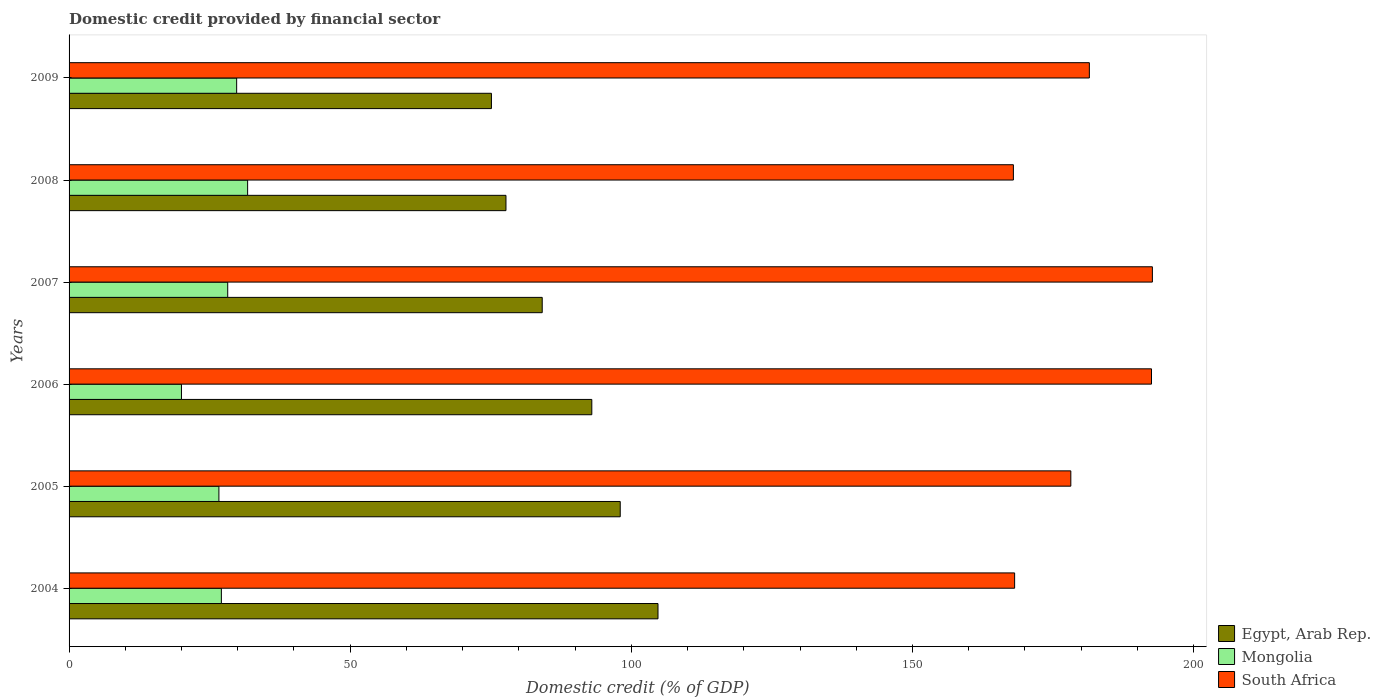How many groups of bars are there?
Your answer should be compact. 6. Are the number of bars per tick equal to the number of legend labels?
Keep it short and to the point. Yes. Are the number of bars on each tick of the Y-axis equal?
Make the answer very short. Yes. How many bars are there on the 4th tick from the top?
Ensure brevity in your answer.  3. How many bars are there on the 6th tick from the bottom?
Your response must be concise. 3. In how many cases, is the number of bars for a given year not equal to the number of legend labels?
Offer a terse response. 0. What is the domestic credit in Egypt, Arab Rep. in 2005?
Your response must be concise. 98.02. Across all years, what is the maximum domestic credit in Mongolia?
Offer a terse response. 31.76. Across all years, what is the minimum domestic credit in South Africa?
Ensure brevity in your answer.  167.94. In which year was the domestic credit in Egypt, Arab Rep. maximum?
Your answer should be very brief. 2004. What is the total domestic credit in Egypt, Arab Rep. in the graph?
Keep it short and to the point. 532.68. What is the difference between the domestic credit in Egypt, Arab Rep. in 2005 and that in 2007?
Offer a very short reply. 13.87. What is the difference between the domestic credit in Egypt, Arab Rep. in 2004 and the domestic credit in Mongolia in 2009?
Your answer should be compact. 74.93. What is the average domestic credit in South Africa per year?
Keep it short and to the point. 180.14. In the year 2005, what is the difference between the domestic credit in Egypt, Arab Rep. and domestic credit in South Africa?
Offer a terse response. -80.13. In how many years, is the domestic credit in South Africa greater than 80 %?
Provide a succinct answer. 6. What is the ratio of the domestic credit in South Africa in 2007 to that in 2009?
Provide a succinct answer. 1.06. Is the domestic credit in South Africa in 2005 less than that in 2007?
Make the answer very short. Yes. Is the difference between the domestic credit in Egypt, Arab Rep. in 2006 and 2009 greater than the difference between the domestic credit in South Africa in 2006 and 2009?
Ensure brevity in your answer.  Yes. What is the difference between the highest and the second highest domestic credit in South Africa?
Offer a terse response. 0.16. What is the difference between the highest and the lowest domestic credit in South Africa?
Your answer should be compact. 24.72. Is the sum of the domestic credit in Egypt, Arab Rep. in 2005 and 2006 greater than the maximum domestic credit in South Africa across all years?
Offer a very short reply. No. What does the 3rd bar from the top in 2005 represents?
Ensure brevity in your answer.  Egypt, Arab Rep. What does the 3rd bar from the bottom in 2005 represents?
Keep it short and to the point. South Africa. How many bars are there?
Keep it short and to the point. 18. What is the difference between two consecutive major ticks on the X-axis?
Your answer should be very brief. 50. Are the values on the major ticks of X-axis written in scientific E-notation?
Give a very brief answer. No. Does the graph contain any zero values?
Your answer should be compact. No. Does the graph contain grids?
Make the answer very short. No. Where does the legend appear in the graph?
Offer a very short reply. Bottom right. How many legend labels are there?
Your response must be concise. 3. How are the legend labels stacked?
Ensure brevity in your answer.  Vertical. What is the title of the graph?
Keep it short and to the point. Domestic credit provided by financial sector. What is the label or title of the X-axis?
Provide a short and direct response. Domestic credit (% of GDP). What is the Domestic credit (% of GDP) in Egypt, Arab Rep. in 2004?
Provide a short and direct response. 104.74. What is the Domestic credit (% of GDP) in Mongolia in 2004?
Make the answer very short. 27.09. What is the Domestic credit (% of GDP) of South Africa in 2004?
Offer a very short reply. 168.16. What is the Domestic credit (% of GDP) of Egypt, Arab Rep. in 2005?
Your answer should be compact. 98.02. What is the Domestic credit (% of GDP) in Mongolia in 2005?
Your answer should be compact. 26.65. What is the Domestic credit (% of GDP) in South Africa in 2005?
Your answer should be compact. 178.16. What is the Domestic credit (% of GDP) in Egypt, Arab Rep. in 2006?
Keep it short and to the point. 92.97. What is the Domestic credit (% of GDP) in Mongolia in 2006?
Offer a terse response. 19.99. What is the Domestic credit (% of GDP) in South Africa in 2006?
Keep it short and to the point. 192.5. What is the Domestic credit (% of GDP) in Egypt, Arab Rep. in 2007?
Ensure brevity in your answer.  84.15. What is the Domestic credit (% of GDP) in Mongolia in 2007?
Your answer should be compact. 28.21. What is the Domestic credit (% of GDP) in South Africa in 2007?
Keep it short and to the point. 192.66. What is the Domestic credit (% of GDP) of Egypt, Arab Rep. in 2008?
Provide a succinct answer. 77.7. What is the Domestic credit (% of GDP) in Mongolia in 2008?
Give a very brief answer. 31.76. What is the Domestic credit (% of GDP) in South Africa in 2008?
Offer a very short reply. 167.94. What is the Domestic credit (% of GDP) of Egypt, Arab Rep. in 2009?
Keep it short and to the point. 75.11. What is the Domestic credit (% of GDP) of Mongolia in 2009?
Your answer should be compact. 29.8. What is the Domestic credit (% of GDP) of South Africa in 2009?
Make the answer very short. 181.45. Across all years, what is the maximum Domestic credit (% of GDP) of Egypt, Arab Rep.?
Make the answer very short. 104.74. Across all years, what is the maximum Domestic credit (% of GDP) in Mongolia?
Offer a terse response. 31.76. Across all years, what is the maximum Domestic credit (% of GDP) in South Africa?
Provide a short and direct response. 192.66. Across all years, what is the minimum Domestic credit (% of GDP) in Egypt, Arab Rep.?
Ensure brevity in your answer.  75.11. Across all years, what is the minimum Domestic credit (% of GDP) of Mongolia?
Provide a succinct answer. 19.99. Across all years, what is the minimum Domestic credit (% of GDP) in South Africa?
Provide a succinct answer. 167.94. What is the total Domestic credit (% of GDP) in Egypt, Arab Rep. in the graph?
Your answer should be very brief. 532.68. What is the total Domestic credit (% of GDP) of Mongolia in the graph?
Your answer should be very brief. 163.49. What is the total Domestic credit (% of GDP) in South Africa in the graph?
Your answer should be very brief. 1080.87. What is the difference between the Domestic credit (% of GDP) in Egypt, Arab Rep. in 2004 and that in 2005?
Provide a succinct answer. 6.72. What is the difference between the Domestic credit (% of GDP) of Mongolia in 2004 and that in 2005?
Give a very brief answer. 0.44. What is the difference between the Domestic credit (% of GDP) in South Africa in 2004 and that in 2005?
Your answer should be compact. -10. What is the difference between the Domestic credit (% of GDP) of Egypt, Arab Rep. in 2004 and that in 2006?
Your response must be concise. 11.77. What is the difference between the Domestic credit (% of GDP) in Mongolia in 2004 and that in 2006?
Your response must be concise. 7.1. What is the difference between the Domestic credit (% of GDP) in South Africa in 2004 and that in 2006?
Your response must be concise. -24.34. What is the difference between the Domestic credit (% of GDP) in Egypt, Arab Rep. in 2004 and that in 2007?
Give a very brief answer. 20.59. What is the difference between the Domestic credit (% of GDP) of Mongolia in 2004 and that in 2007?
Provide a short and direct response. -1.13. What is the difference between the Domestic credit (% of GDP) of South Africa in 2004 and that in 2007?
Offer a terse response. -24.5. What is the difference between the Domestic credit (% of GDP) of Egypt, Arab Rep. in 2004 and that in 2008?
Keep it short and to the point. 27.04. What is the difference between the Domestic credit (% of GDP) of Mongolia in 2004 and that in 2008?
Offer a very short reply. -4.67. What is the difference between the Domestic credit (% of GDP) of South Africa in 2004 and that in 2008?
Make the answer very short. 0.22. What is the difference between the Domestic credit (% of GDP) in Egypt, Arab Rep. in 2004 and that in 2009?
Offer a terse response. 29.62. What is the difference between the Domestic credit (% of GDP) of Mongolia in 2004 and that in 2009?
Offer a terse response. -2.72. What is the difference between the Domestic credit (% of GDP) in South Africa in 2004 and that in 2009?
Make the answer very short. -13.29. What is the difference between the Domestic credit (% of GDP) in Egypt, Arab Rep. in 2005 and that in 2006?
Offer a very short reply. 5.05. What is the difference between the Domestic credit (% of GDP) in Mongolia in 2005 and that in 2006?
Offer a very short reply. 6.66. What is the difference between the Domestic credit (% of GDP) in South Africa in 2005 and that in 2006?
Provide a short and direct response. -14.35. What is the difference between the Domestic credit (% of GDP) of Egypt, Arab Rep. in 2005 and that in 2007?
Make the answer very short. 13.87. What is the difference between the Domestic credit (% of GDP) in Mongolia in 2005 and that in 2007?
Your answer should be compact. -1.57. What is the difference between the Domestic credit (% of GDP) in South Africa in 2005 and that in 2007?
Give a very brief answer. -14.5. What is the difference between the Domestic credit (% of GDP) of Egypt, Arab Rep. in 2005 and that in 2008?
Ensure brevity in your answer.  20.32. What is the difference between the Domestic credit (% of GDP) of Mongolia in 2005 and that in 2008?
Make the answer very short. -5.11. What is the difference between the Domestic credit (% of GDP) of South Africa in 2005 and that in 2008?
Ensure brevity in your answer.  10.21. What is the difference between the Domestic credit (% of GDP) in Egypt, Arab Rep. in 2005 and that in 2009?
Provide a short and direct response. 22.91. What is the difference between the Domestic credit (% of GDP) in Mongolia in 2005 and that in 2009?
Provide a succinct answer. -3.16. What is the difference between the Domestic credit (% of GDP) of South Africa in 2005 and that in 2009?
Provide a short and direct response. -3.29. What is the difference between the Domestic credit (% of GDP) of Egypt, Arab Rep. in 2006 and that in 2007?
Give a very brief answer. 8.82. What is the difference between the Domestic credit (% of GDP) in Mongolia in 2006 and that in 2007?
Offer a very short reply. -8.23. What is the difference between the Domestic credit (% of GDP) of South Africa in 2006 and that in 2007?
Your response must be concise. -0.16. What is the difference between the Domestic credit (% of GDP) in Egypt, Arab Rep. in 2006 and that in 2008?
Give a very brief answer. 15.27. What is the difference between the Domestic credit (% of GDP) in Mongolia in 2006 and that in 2008?
Offer a very short reply. -11.77. What is the difference between the Domestic credit (% of GDP) in South Africa in 2006 and that in 2008?
Offer a terse response. 24.56. What is the difference between the Domestic credit (% of GDP) in Egypt, Arab Rep. in 2006 and that in 2009?
Offer a very short reply. 17.85. What is the difference between the Domestic credit (% of GDP) in Mongolia in 2006 and that in 2009?
Ensure brevity in your answer.  -9.82. What is the difference between the Domestic credit (% of GDP) of South Africa in 2006 and that in 2009?
Your answer should be very brief. 11.05. What is the difference between the Domestic credit (% of GDP) in Egypt, Arab Rep. in 2007 and that in 2008?
Make the answer very short. 6.45. What is the difference between the Domestic credit (% of GDP) of Mongolia in 2007 and that in 2008?
Your response must be concise. -3.54. What is the difference between the Domestic credit (% of GDP) in South Africa in 2007 and that in 2008?
Your answer should be very brief. 24.72. What is the difference between the Domestic credit (% of GDP) in Egypt, Arab Rep. in 2007 and that in 2009?
Make the answer very short. 9.03. What is the difference between the Domestic credit (% of GDP) of Mongolia in 2007 and that in 2009?
Offer a terse response. -1.59. What is the difference between the Domestic credit (% of GDP) in South Africa in 2007 and that in 2009?
Provide a succinct answer. 11.21. What is the difference between the Domestic credit (% of GDP) of Egypt, Arab Rep. in 2008 and that in 2009?
Your answer should be very brief. 2.58. What is the difference between the Domestic credit (% of GDP) of Mongolia in 2008 and that in 2009?
Offer a very short reply. 1.95. What is the difference between the Domestic credit (% of GDP) of South Africa in 2008 and that in 2009?
Your response must be concise. -13.51. What is the difference between the Domestic credit (% of GDP) in Egypt, Arab Rep. in 2004 and the Domestic credit (% of GDP) in Mongolia in 2005?
Your answer should be compact. 78.09. What is the difference between the Domestic credit (% of GDP) of Egypt, Arab Rep. in 2004 and the Domestic credit (% of GDP) of South Africa in 2005?
Keep it short and to the point. -73.42. What is the difference between the Domestic credit (% of GDP) in Mongolia in 2004 and the Domestic credit (% of GDP) in South Africa in 2005?
Your answer should be very brief. -151.07. What is the difference between the Domestic credit (% of GDP) of Egypt, Arab Rep. in 2004 and the Domestic credit (% of GDP) of Mongolia in 2006?
Your response must be concise. 84.75. What is the difference between the Domestic credit (% of GDP) of Egypt, Arab Rep. in 2004 and the Domestic credit (% of GDP) of South Africa in 2006?
Offer a terse response. -87.77. What is the difference between the Domestic credit (% of GDP) in Mongolia in 2004 and the Domestic credit (% of GDP) in South Africa in 2006?
Provide a succinct answer. -165.42. What is the difference between the Domestic credit (% of GDP) in Egypt, Arab Rep. in 2004 and the Domestic credit (% of GDP) in Mongolia in 2007?
Make the answer very short. 76.52. What is the difference between the Domestic credit (% of GDP) of Egypt, Arab Rep. in 2004 and the Domestic credit (% of GDP) of South Africa in 2007?
Give a very brief answer. -87.92. What is the difference between the Domestic credit (% of GDP) in Mongolia in 2004 and the Domestic credit (% of GDP) in South Africa in 2007?
Provide a short and direct response. -165.57. What is the difference between the Domestic credit (% of GDP) of Egypt, Arab Rep. in 2004 and the Domestic credit (% of GDP) of Mongolia in 2008?
Ensure brevity in your answer.  72.98. What is the difference between the Domestic credit (% of GDP) of Egypt, Arab Rep. in 2004 and the Domestic credit (% of GDP) of South Africa in 2008?
Your answer should be very brief. -63.2. What is the difference between the Domestic credit (% of GDP) of Mongolia in 2004 and the Domestic credit (% of GDP) of South Africa in 2008?
Provide a short and direct response. -140.85. What is the difference between the Domestic credit (% of GDP) of Egypt, Arab Rep. in 2004 and the Domestic credit (% of GDP) of Mongolia in 2009?
Ensure brevity in your answer.  74.93. What is the difference between the Domestic credit (% of GDP) of Egypt, Arab Rep. in 2004 and the Domestic credit (% of GDP) of South Africa in 2009?
Ensure brevity in your answer.  -76.71. What is the difference between the Domestic credit (% of GDP) of Mongolia in 2004 and the Domestic credit (% of GDP) of South Africa in 2009?
Ensure brevity in your answer.  -154.36. What is the difference between the Domestic credit (% of GDP) in Egypt, Arab Rep. in 2005 and the Domestic credit (% of GDP) in Mongolia in 2006?
Provide a short and direct response. 78.03. What is the difference between the Domestic credit (% of GDP) in Egypt, Arab Rep. in 2005 and the Domestic credit (% of GDP) in South Africa in 2006?
Provide a succinct answer. -94.48. What is the difference between the Domestic credit (% of GDP) in Mongolia in 2005 and the Domestic credit (% of GDP) in South Africa in 2006?
Your answer should be compact. -165.86. What is the difference between the Domestic credit (% of GDP) of Egypt, Arab Rep. in 2005 and the Domestic credit (% of GDP) of Mongolia in 2007?
Provide a succinct answer. 69.81. What is the difference between the Domestic credit (% of GDP) in Egypt, Arab Rep. in 2005 and the Domestic credit (% of GDP) in South Africa in 2007?
Offer a very short reply. -94.64. What is the difference between the Domestic credit (% of GDP) in Mongolia in 2005 and the Domestic credit (% of GDP) in South Africa in 2007?
Ensure brevity in your answer.  -166.01. What is the difference between the Domestic credit (% of GDP) of Egypt, Arab Rep. in 2005 and the Domestic credit (% of GDP) of Mongolia in 2008?
Offer a terse response. 66.27. What is the difference between the Domestic credit (% of GDP) of Egypt, Arab Rep. in 2005 and the Domestic credit (% of GDP) of South Africa in 2008?
Give a very brief answer. -69.92. What is the difference between the Domestic credit (% of GDP) in Mongolia in 2005 and the Domestic credit (% of GDP) in South Africa in 2008?
Give a very brief answer. -141.3. What is the difference between the Domestic credit (% of GDP) of Egypt, Arab Rep. in 2005 and the Domestic credit (% of GDP) of Mongolia in 2009?
Provide a succinct answer. 68.22. What is the difference between the Domestic credit (% of GDP) in Egypt, Arab Rep. in 2005 and the Domestic credit (% of GDP) in South Africa in 2009?
Keep it short and to the point. -83.43. What is the difference between the Domestic credit (% of GDP) in Mongolia in 2005 and the Domestic credit (% of GDP) in South Africa in 2009?
Ensure brevity in your answer.  -154.8. What is the difference between the Domestic credit (% of GDP) of Egypt, Arab Rep. in 2006 and the Domestic credit (% of GDP) of Mongolia in 2007?
Provide a succinct answer. 64.75. What is the difference between the Domestic credit (% of GDP) of Egypt, Arab Rep. in 2006 and the Domestic credit (% of GDP) of South Africa in 2007?
Offer a terse response. -99.69. What is the difference between the Domestic credit (% of GDP) of Mongolia in 2006 and the Domestic credit (% of GDP) of South Africa in 2007?
Provide a short and direct response. -172.67. What is the difference between the Domestic credit (% of GDP) in Egypt, Arab Rep. in 2006 and the Domestic credit (% of GDP) in Mongolia in 2008?
Ensure brevity in your answer.  61.21. What is the difference between the Domestic credit (% of GDP) of Egypt, Arab Rep. in 2006 and the Domestic credit (% of GDP) of South Africa in 2008?
Your answer should be very brief. -74.97. What is the difference between the Domestic credit (% of GDP) of Mongolia in 2006 and the Domestic credit (% of GDP) of South Africa in 2008?
Offer a terse response. -147.95. What is the difference between the Domestic credit (% of GDP) of Egypt, Arab Rep. in 2006 and the Domestic credit (% of GDP) of Mongolia in 2009?
Your answer should be very brief. 63.16. What is the difference between the Domestic credit (% of GDP) of Egypt, Arab Rep. in 2006 and the Domestic credit (% of GDP) of South Africa in 2009?
Give a very brief answer. -88.48. What is the difference between the Domestic credit (% of GDP) of Mongolia in 2006 and the Domestic credit (% of GDP) of South Africa in 2009?
Your answer should be compact. -161.46. What is the difference between the Domestic credit (% of GDP) in Egypt, Arab Rep. in 2007 and the Domestic credit (% of GDP) in Mongolia in 2008?
Provide a succinct answer. 52.39. What is the difference between the Domestic credit (% of GDP) in Egypt, Arab Rep. in 2007 and the Domestic credit (% of GDP) in South Africa in 2008?
Your answer should be compact. -83.79. What is the difference between the Domestic credit (% of GDP) of Mongolia in 2007 and the Domestic credit (% of GDP) of South Africa in 2008?
Your response must be concise. -139.73. What is the difference between the Domestic credit (% of GDP) in Egypt, Arab Rep. in 2007 and the Domestic credit (% of GDP) in Mongolia in 2009?
Offer a terse response. 54.34. What is the difference between the Domestic credit (% of GDP) in Egypt, Arab Rep. in 2007 and the Domestic credit (% of GDP) in South Africa in 2009?
Offer a very short reply. -97.3. What is the difference between the Domestic credit (% of GDP) of Mongolia in 2007 and the Domestic credit (% of GDP) of South Africa in 2009?
Provide a short and direct response. -153.24. What is the difference between the Domestic credit (% of GDP) in Egypt, Arab Rep. in 2008 and the Domestic credit (% of GDP) in Mongolia in 2009?
Keep it short and to the point. 47.89. What is the difference between the Domestic credit (% of GDP) in Egypt, Arab Rep. in 2008 and the Domestic credit (% of GDP) in South Africa in 2009?
Your response must be concise. -103.75. What is the difference between the Domestic credit (% of GDP) in Mongolia in 2008 and the Domestic credit (% of GDP) in South Africa in 2009?
Offer a very short reply. -149.69. What is the average Domestic credit (% of GDP) in Egypt, Arab Rep. per year?
Ensure brevity in your answer.  88.78. What is the average Domestic credit (% of GDP) of Mongolia per year?
Your response must be concise. 27.25. What is the average Domestic credit (% of GDP) in South Africa per year?
Your answer should be compact. 180.14. In the year 2004, what is the difference between the Domestic credit (% of GDP) of Egypt, Arab Rep. and Domestic credit (% of GDP) of Mongolia?
Give a very brief answer. 77.65. In the year 2004, what is the difference between the Domestic credit (% of GDP) in Egypt, Arab Rep. and Domestic credit (% of GDP) in South Africa?
Give a very brief answer. -63.42. In the year 2004, what is the difference between the Domestic credit (% of GDP) of Mongolia and Domestic credit (% of GDP) of South Africa?
Provide a succinct answer. -141.07. In the year 2005, what is the difference between the Domestic credit (% of GDP) of Egypt, Arab Rep. and Domestic credit (% of GDP) of Mongolia?
Ensure brevity in your answer.  71.38. In the year 2005, what is the difference between the Domestic credit (% of GDP) of Egypt, Arab Rep. and Domestic credit (% of GDP) of South Africa?
Ensure brevity in your answer.  -80.13. In the year 2005, what is the difference between the Domestic credit (% of GDP) of Mongolia and Domestic credit (% of GDP) of South Africa?
Offer a very short reply. -151.51. In the year 2006, what is the difference between the Domestic credit (% of GDP) in Egypt, Arab Rep. and Domestic credit (% of GDP) in Mongolia?
Keep it short and to the point. 72.98. In the year 2006, what is the difference between the Domestic credit (% of GDP) of Egypt, Arab Rep. and Domestic credit (% of GDP) of South Africa?
Keep it short and to the point. -99.54. In the year 2006, what is the difference between the Domestic credit (% of GDP) in Mongolia and Domestic credit (% of GDP) in South Africa?
Your answer should be very brief. -172.51. In the year 2007, what is the difference between the Domestic credit (% of GDP) of Egypt, Arab Rep. and Domestic credit (% of GDP) of Mongolia?
Your answer should be very brief. 55.93. In the year 2007, what is the difference between the Domestic credit (% of GDP) in Egypt, Arab Rep. and Domestic credit (% of GDP) in South Africa?
Give a very brief answer. -108.51. In the year 2007, what is the difference between the Domestic credit (% of GDP) in Mongolia and Domestic credit (% of GDP) in South Africa?
Keep it short and to the point. -164.45. In the year 2008, what is the difference between the Domestic credit (% of GDP) of Egypt, Arab Rep. and Domestic credit (% of GDP) of Mongolia?
Provide a short and direct response. 45.94. In the year 2008, what is the difference between the Domestic credit (% of GDP) of Egypt, Arab Rep. and Domestic credit (% of GDP) of South Africa?
Offer a terse response. -90.24. In the year 2008, what is the difference between the Domestic credit (% of GDP) of Mongolia and Domestic credit (% of GDP) of South Africa?
Your response must be concise. -136.19. In the year 2009, what is the difference between the Domestic credit (% of GDP) in Egypt, Arab Rep. and Domestic credit (% of GDP) in Mongolia?
Your answer should be very brief. 45.31. In the year 2009, what is the difference between the Domestic credit (% of GDP) of Egypt, Arab Rep. and Domestic credit (% of GDP) of South Africa?
Your answer should be very brief. -106.34. In the year 2009, what is the difference between the Domestic credit (% of GDP) of Mongolia and Domestic credit (% of GDP) of South Africa?
Your answer should be compact. -151.65. What is the ratio of the Domestic credit (% of GDP) in Egypt, Arab Rep. in 2004 to that in 2005?
Provide a short and direct response. 1.07. What is the ratio of the Domestic credit (% of GDP) of Mongolia in 2004 to that in 2005?
Your answer should be very brief. 1.02. What is the ratio of the Domestic credit (% of GDP) in South Africa in 2004 to that in 2005?
Provide a succinct answer. 0.94. What is the ratio of the Domestic credit (% of GDP) in Egypt, Arab Rep. in 2004 to that in 2006?
Offer a very short reply. 1.13. What is the ratio of the Domestic credit (% of GDP) in Mongolia in 2004 to that in 2006?
Provide a succinct answer. 1.36. What is the ratio of the Domestic credit (% of GDP) in South Africa in 2004 to that in 2006?
Ensure brevity in your answer.  0.87. What is the ratio of the Domestic credit (% of GDP) in Egypt, Arab Rep. in 2004 to that in 2007?
Provide a succinct answer. 1.24. What is the ratio of the Domestic credit (% of GDP) in Mongolia in 2004 to that in 2007?
Keep it short and to the point. 0.96. What is the ratio of the Domestic credit (% of GDP) in South Africa in 2004 to that in 2007?
Your response must be concise. 0.87. What is the ratio of the Domestic credit (% of GDP) in Egypt, Arab Rep. in 2004 to that in 2008?
Your answer should be very brief. 1.35. What is the ratio of the Domestic credit (% of GDP) of Mongolia in 2004 to that in 2008?
Provide a succinct answer. 0.85. What is the ratio of the Domestic credit (% of GDP) of Egypt, Arab Rep. in 2004 to that in 2009?
Offer a very short reply. 1.39. What is the ratio of the Domestic credit (% of GDP) of Mongolia in 2004 to that in 2009?
Give a very brief answer. 0.91. What is the ratio of the Domestic credit (% of GDP) in South Africa in 2004 to that in 2009?
Give a very brief answer. 0.93. What is the ratio of the Domestic credit (% of GDP) of Egypt, Arab Rep. in 2005 to that in 2006?
Keep it short and to the point. 1.05. What is the ratio of the Domestic credit (% of GDP) in Mongolia in 2005 to that in 2006?
Keep it short and to the point. 1.33. What is the ratio of the Domestic credit (% of GDP) in South Africa in 2005 to that in 2006?
Offer a very short reply. 0.93. What is the ratio of the Domestic credit (% of GDP) in Egypt, Arab Rep. in 2005 to that in 2007?
Offer a very short reply. 1.16. What is the ratio of the Domestic credit (% of GDP) of Mongolia in 2005 to that in 2007?
Keep it short and to the point. 0.94. What is the ratio of the Domestic credit (% of GDP) of South Africa in 2005 to that in 2007?
Your answer should be compact. 0.92. What is the ratio of the Domestic credit (% of GDP) in Egypt, Arab Rep. in 2005 to that in 2008?
Make the answer very short. 1.26. What is the ratio of the Domestic credit (% of GDP) in Mongolia in 2005 to that in 2008?
Give a very brief answer. 0.84. What is the ratio of the Domestic credit (% of GDP) in South Africa in 2005 to that in 2008?
Ensure brevity in your answer.  1.06. What is the ratio of the Domestic credit (% of GDP) in Egypt, Arab Rep. in 2005 to that in 2009?
Provide a short and direct response. 1.3. What is the ratio of the Domestic credit (% of GDP) of Mongolia in 2005 to that in 2009?
Ensure brevity in your answer.  0.89. What is the ratio of the Domestic credit (% of GDP) of South Africa in 2005 to that in 2009?
Ensure brevity in your answer.  0.98. What is the ratio of the Domestic credit (% of GDP) in Egypt, Arab Rep. in 2006 to that in 2007?
Provide a short and direct response. 1.1. What is the ratio of the Domestic credit (% of GDP) in Mongolia in 2006 to that in 2007?
Your answer should be very brief. 0.71. What is the ratio of the Domestic credit (% of GDP) in Egypt, Arab Rep. in 2006 to that in 2008?
Offer a very short reply. 1.2. What is the ratio of the Domestic credit (% of GDP) of Mongolia in 2006 to that in 2008?
Provide a short and direct response. 0.63. What is the ratio of the Domestic credit (% of GDP) in South Africa in 2006 to that in 2008?
Make the answer very short. 1.15. What is the ratio of the Domestic credit (% of GDP) of Egypt, Arab Rep. in 2006 to that in 2009?
Your response must be concise. 1.24. What is the ratio of the Domestic credit (% of GDP) in Mongolia in 2006 to that in 2009?
Provide a short and direct response. 0.67. What is the ratio of the Domestic credit (% of GDP) in South Africa in 2006 to that in 2009?
Make the answer very short. 1.06. What is the ratio of the Domestic credit (% of GDP) in Egypt, Arab Rep. in 2007 to that in 2008?
Make the answer very short. 1.08. What is the ratio of the Domestic credit (% of GDP) of Mongolia in 2007 to that in 2008?
Give a very brief answer. 0.89. What is the ratio of the Domestic credit (% of GDP) of South Africa in 2007 to that in 2008?
Provide a short and direct response. 1.15. What is the ratio of the Domestic credit (% of GDP) of Egypt, Arab Rep. in 2007 to that in 2009?
Ensure brevity in your answer.  1.12. What is the ratio of the Domestic credit (% of GDP) of Mongolia in 2007 to that in 2009?
Ensure brevity in your answer.  0.95. What is the ratio of the Domestic credit (% of GDP) in South Africa in 2007 to that in 2009?
Your answer should be very brief. 1.06. What is the ratio of the Domestic credit (% of GDP) of Egypt, Arab Rep. in 2008 to that in 2009?
Give a very brief answer. 1.03. What is the ratio of the Domestic credit (% of GDP) of Mongolia in 2008 to that in 2009?
Offer a very short reply. 1.07. What is the ratio of the Domestic credit (% of GDP) of South Africa in 2008 to that in 2009?
Ensure brevity in your answer.  0.93. What is the difference between the highest and the second highest Domestic credit (% of GDP) in Egypt, Arab Rep.?
Offer a terse response. 6.72. What is the difference between the highest and the second highest Domestic credit (% of GDP) in Mongolia?
Provide a succinct answer. 1.95. What is the difference between the highest and the second highest Domestic credit (% of GDP) in South Africa?
Your response must be concise. 0.16. What is the difference between the highest and the lowest Domestic credit (% of GDP) in Egypt, Arab Rep.?
Offer a terse response. 29.62. What is the difference between the highest and the lowest Domestic credit (% of GDP) of Mongolia?
Make the answer very short. 11.77. What is the difference between the highest and the lowest Domestic credit (% of GDP) of South Africa?
Keep it short and to the point. 24.72. 